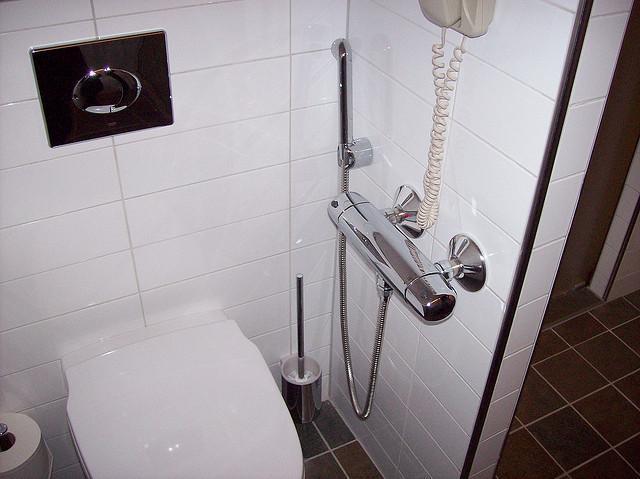How many bears are there?
Give a very brief answer. 0. 